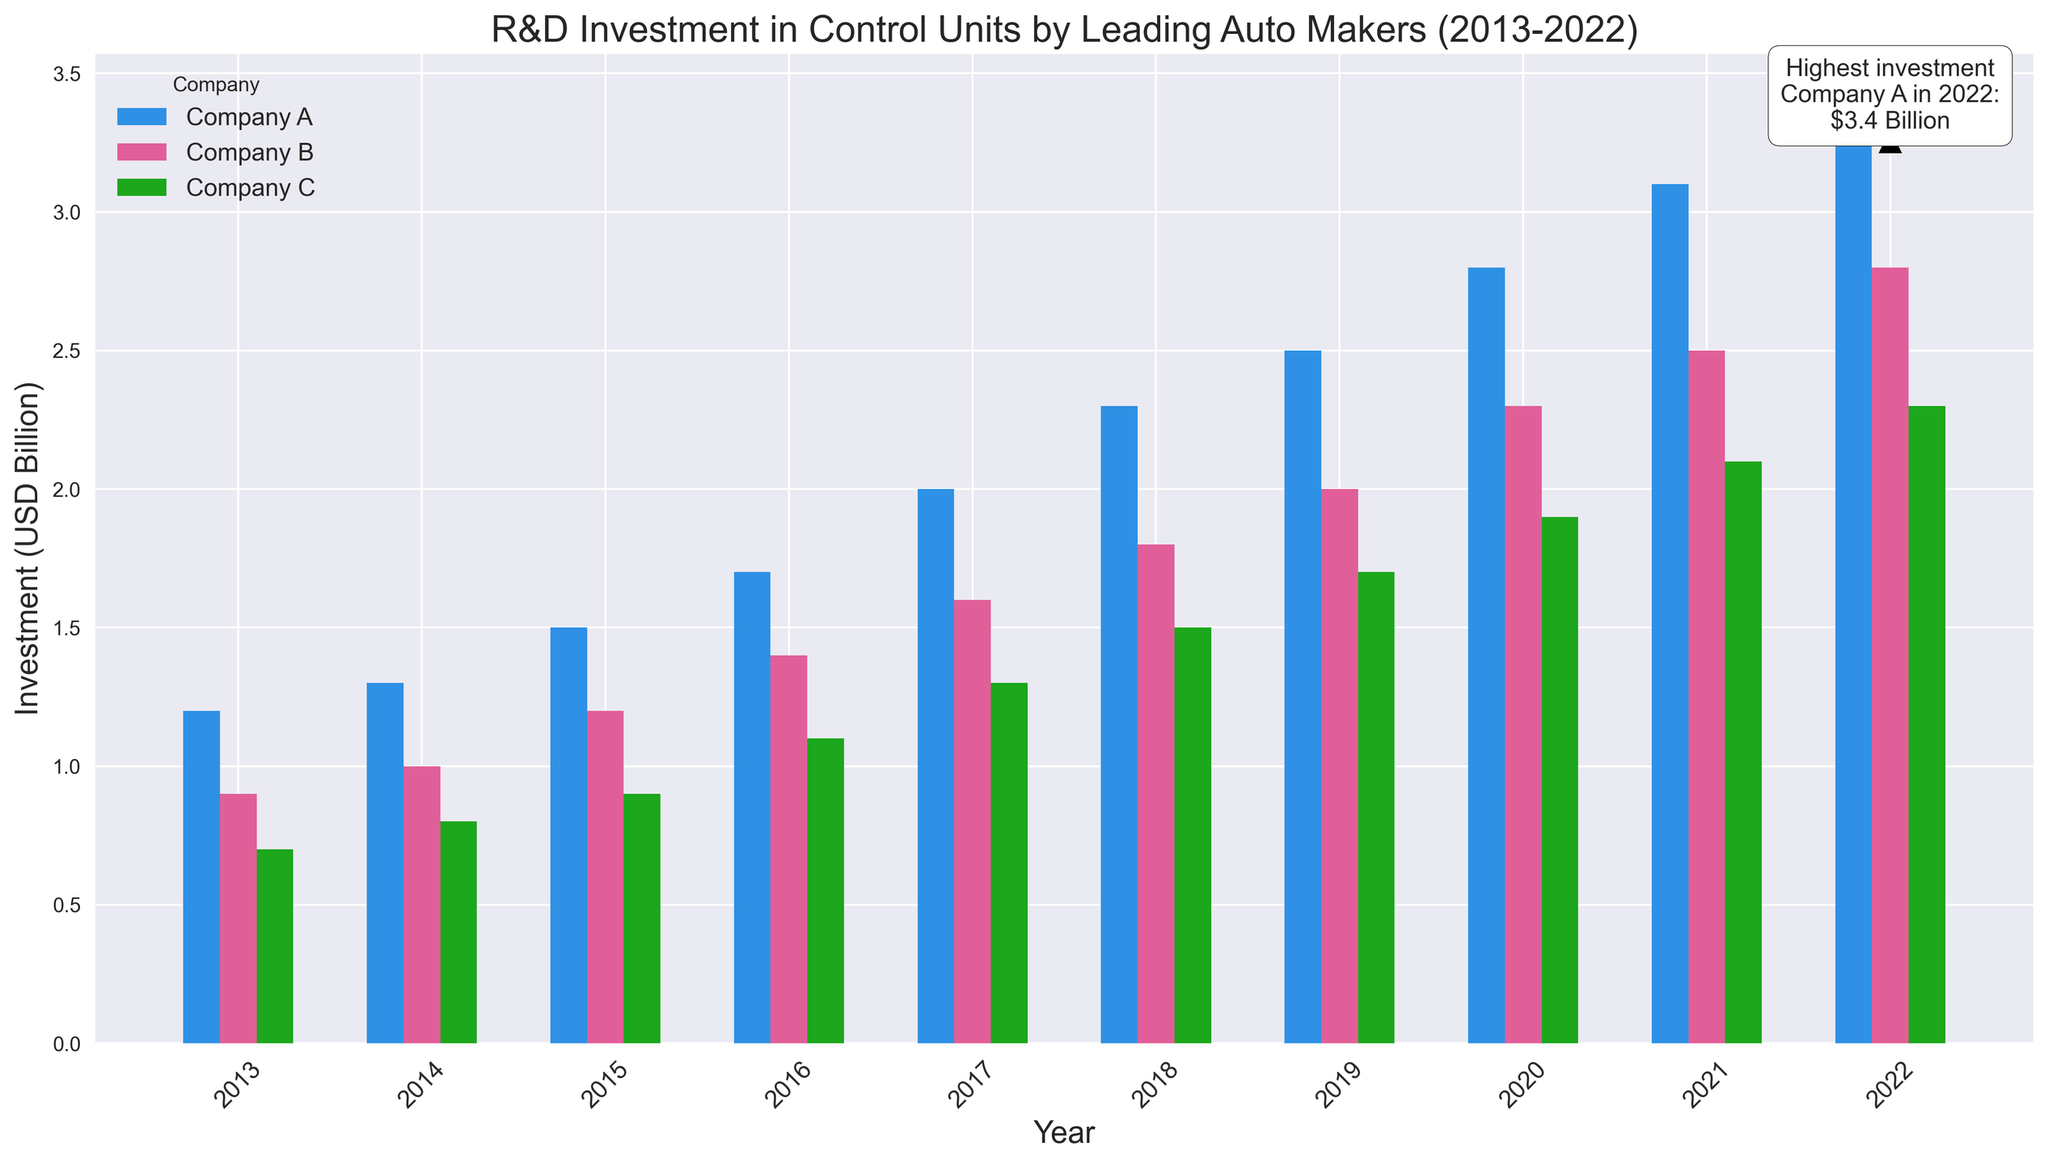Which company had the highest R&D investment in control units in 2022? From the figure, we see three sets of bars corresponding to Company A, Company B, and Company C for each year from 2013 to 2022. In 2022, the tallest bar among the three companies is for Company A, indicating the highest investment.
Answer: Company A What is the trend in R&D investment for Company C over the decade? By looking at the bars representing Company C from 2013 to 2022, we observe that the height of the bars consistently increases, suggesting a steady rise in investments each year.
Answer: Increasing trend How did the R&D investment in control units for Company B change from 2013 to 2020? To find the change, we compare the heights of the bar for Company B in 2013 and 2020. In 2013, the investment is 0.9 billion USD, and in 2020, it is 2.3 billion USD. The difference is 2.3 - 0.9 = 1.4 billion USD.
Answer: Increased by 1.4 billion USD Which company showed the most significant growth in R&D investment between 2015 and 2022? Comparing the heights of the bars for each company in 2015 and 2022, we see the changes are: Company A: 3.4 - 1.5 = 1.9 billion USD, Company B: 2.8 - 1.2 = 1.6 billion USD, Company C: 2.3 - 0.9 = 1.4 billion USD. Company A had the most significant growth.
Answer: Company A Who had the lowest average R&D investment over the decade? To find the average, sum the investments each year for each company and divide by the number of years. Summing up:
Company A: 1.2+1.3+1.5+1.7+2.0+2.3+2.5+2.8+3.1+3.4 = 22.8, Average = 22.8/10 = 2.28
Company B: 0.9+1.0+1.2+1.4+1.6+1.8+2.0+2.3+2.5+2.8 = 17.5, Average = 17.5/10 = 1.75
Company C: 0.7+0.8+0.9+1.1+1.3+1.5+1.7+1.9+2.1+2.3 = 14.3, Average = 14.3/10 = 1.43
Company C has the lowest average.
Answer: Company C What was the total R&D investment for Company A from 2018 to 2020? Adding up the investments for Company A from 2018 to 2020: 2.3 (2018) + 2.5 (2019) + 2.8 (2020) = 7.6 billion USD.
Answer: 7.6 billion USD What year marked the highest recorded R&D investment, and which company made it? From the annotation in the visual, it is stated that the highest investment was made by Company A in 2022, with an investment of 3.4 billion USD.
Answer: 2022, Company A 